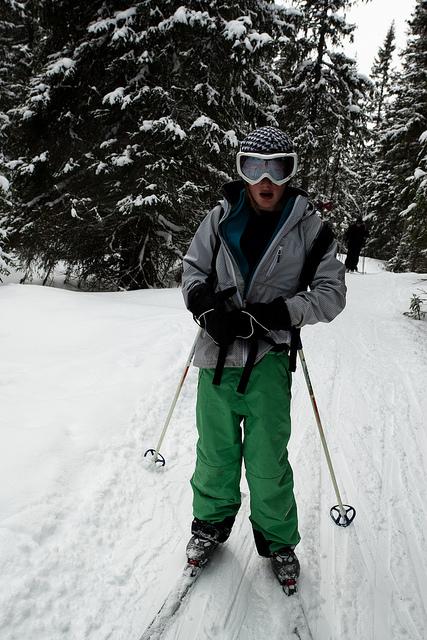Is the man wearing shades?
Be succinct. Yes. Is the person enjoying himself?
Quick response, please. Yes. Do his pants fit?
Write a very short answer. Yes. What activity is the person partaking in?
Quick response, please. Skiing. 